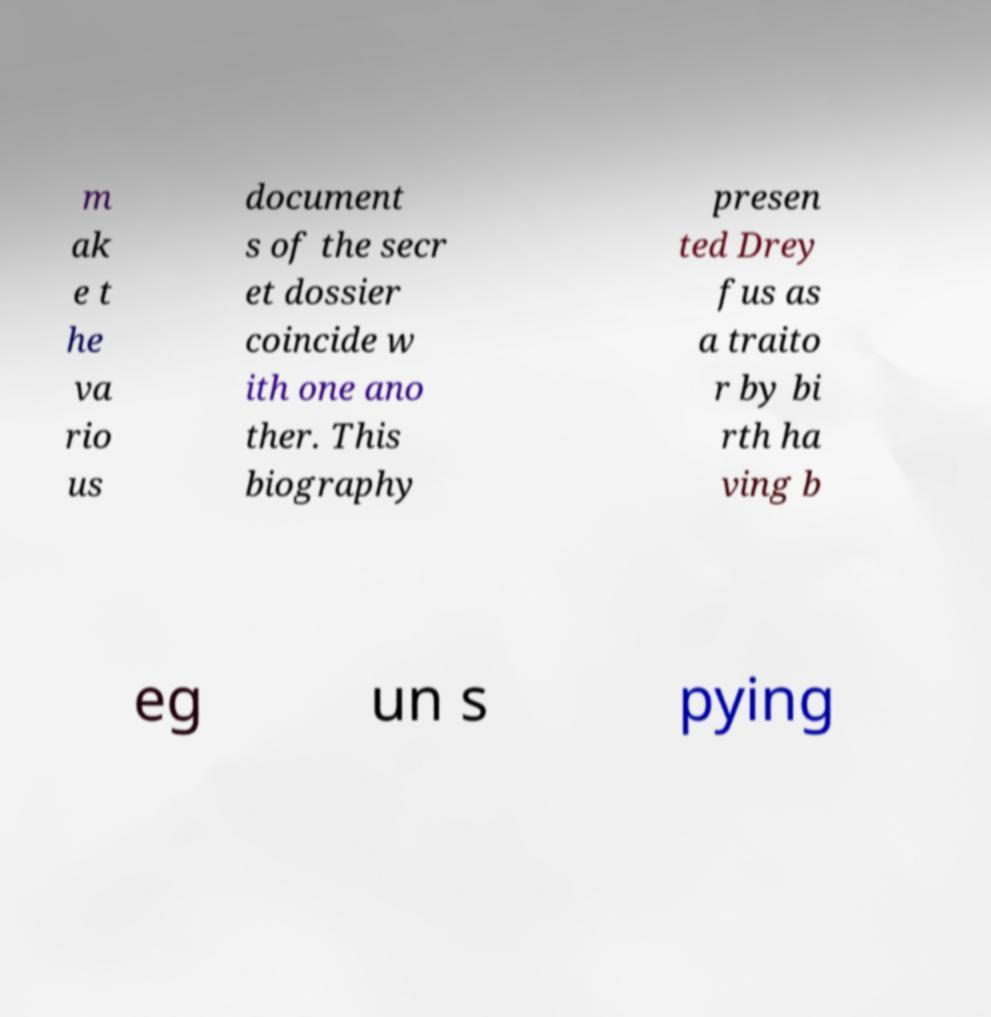What messages or text are displayed in this image? I need them in a readable, typed format. m ak e t he va rio us document s of the secr et dossier coincide w ith one ano ther. This biography presen ted Drey fus as a traito r by bi rth ha ving b eg un s pying 